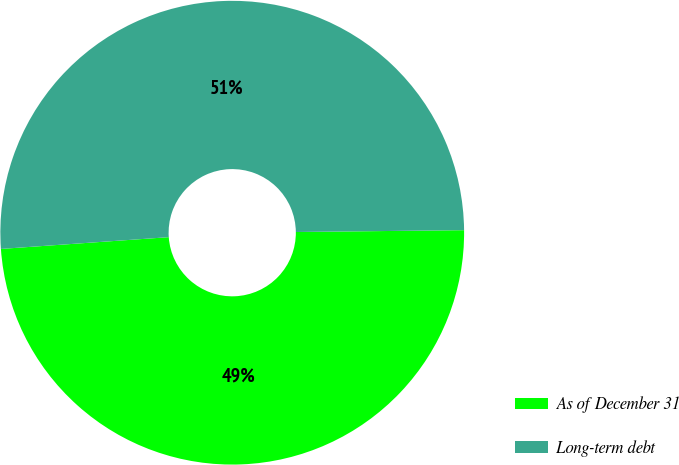Convert chart to OTSL. <chart><loc_0><loc_0><loc_500><loc_500><pie_chart><fcel>As of December 31<fcel>Long-term debt<nl><fcel>49.06%<fcel>50.94%<nl></chart> 